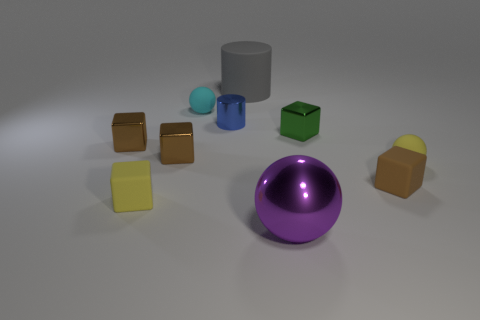Subtract all purple cylinders. How many brown blocks are left? 3 Subtract all yellow blocks. How many blocks are left? 4 Subtract all green cubes. How many cubes are left? 4 Subtract all gray blocks. Subtract all gray balls. How many blocks are left? 5 Subtract all cylinders. How many objects are left? 8 Subtract 0 red blocks. How many objects are left? 10 Subtract all tiny brown shiny cylinders. Subtract all blue things. How many objects are left? 9 Add 1 purple objects. How many purple objects are left? 2 Add 8 blue shiny objects. How many blue shiny objects exist? 9 